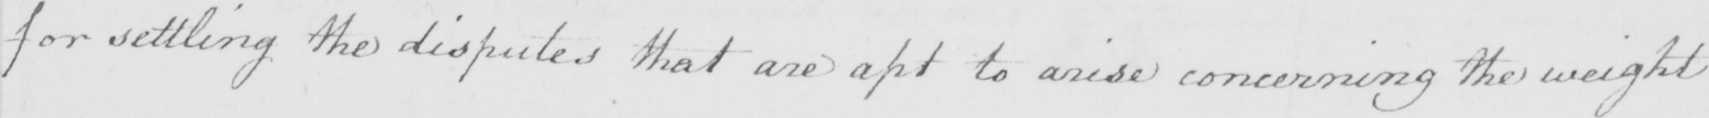What does this handwritten line say? for settling the disputes that are apt to arise concerning the weight 